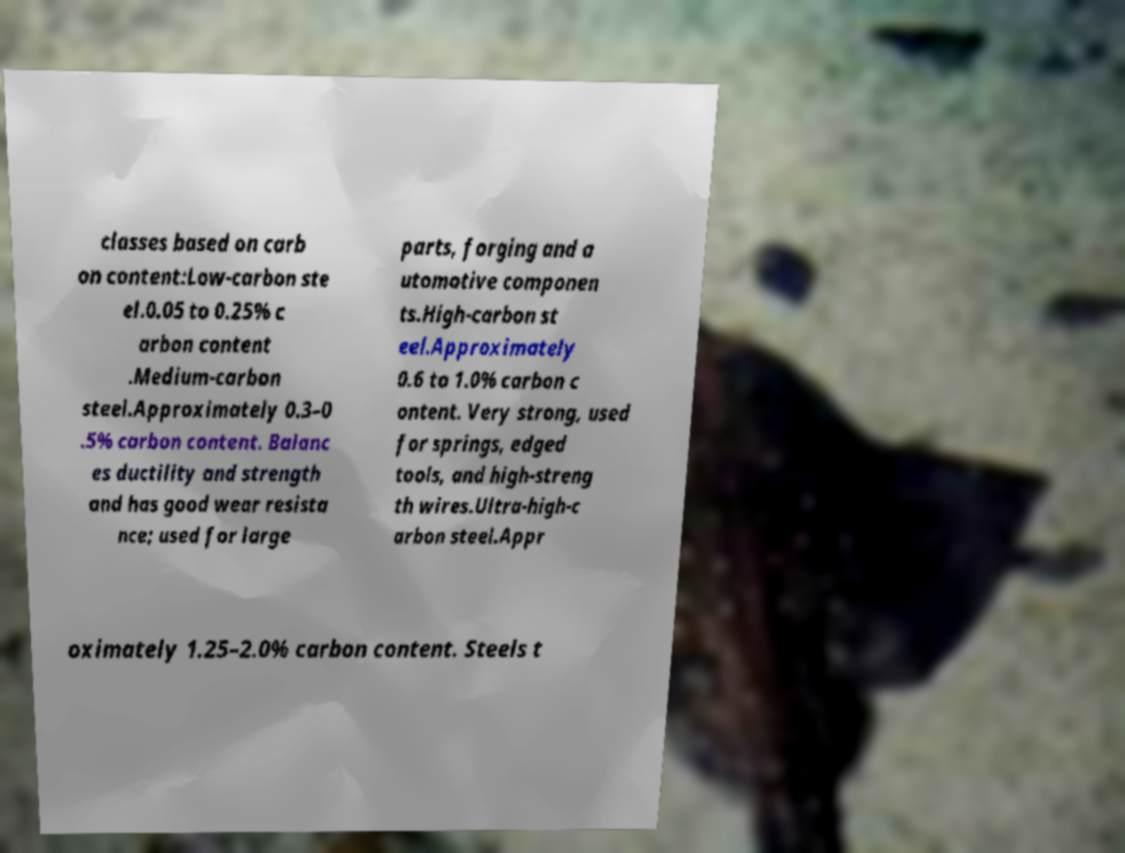For documentation purposes, I need the text within this image transcribed. Could you provide that? classes based on carb on content:Low-carbon ste el.0.05 to 0.25% c arbon content .Medium-carbon steel.Approximately 0.3–0 .5% carbon content. Balanc es ductility and strength and has good wear resista nce; used for large parts, forging and a utomotive componen ts.High-carbon st eel.Approximately 0.6 to 1.0% carbon c ontent. Very strong, used for springs, edged tools, and high-streng th wires.Ultra-high-c arbon steel.Appr oximately 1.25–2.0% carbon content. Steels t 